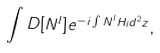Convert formula to latex. <formula><loc_0><loc_0><loc_500><loc_500>\int D [ N ^ { l } ] e ^ { - i \int N ^ { l } H _ { l } d ^ { 2 } z } ,</formula> 